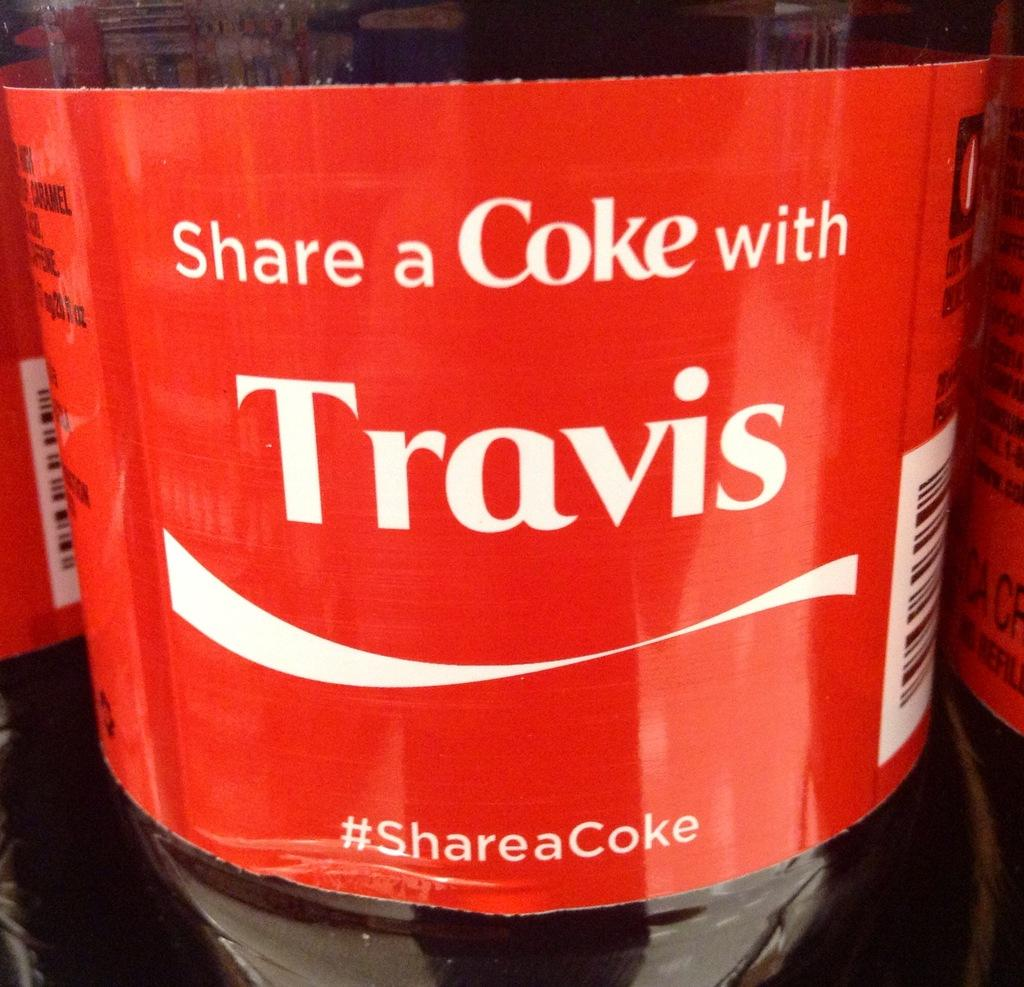What object is present in the image? There is a bottle in the image. What is written on the bottle? The bottle has the words "Share a coke with TRAVIS" written on it. What type of celery is being used to stir the coke in the image? There is no celery present in the image, and the coke is not being stirred. 